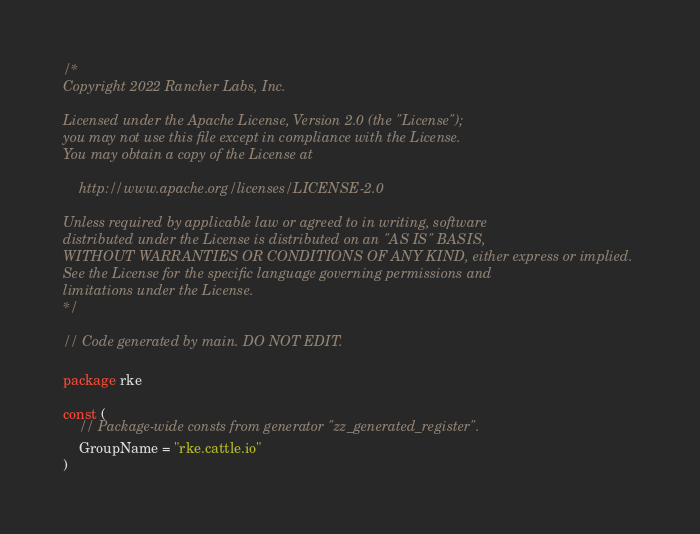<code> <loc_0><loc_0><loc_500><loc_500><_Go_>/*
Copyright 2022 Rancher Labs, Inc.

Licensed under the Apache License, Version 2.0 (the "License");
you may not use this file except in compliance with the License.
You may obtain a copy of the License at

    http://www.apache.org/licenses/LICENSE-2.0

Unless required by applicable law or agreed to in writing, software
distributed under the License is distributed on an "AS IS" BASIS,
WITHOUT WARRANTIES OR CONDITIONS OF ANY KIND, either express or implied.
See the License for the specific language governing permissions and
limitations under the License.
*/

// Code generated by main. DO NOT EDIT.

package rke

const (
	// Package-wide consts from generator "zz_generated_register".
	GroupName = "rke.cattle.io"
)
</code> 